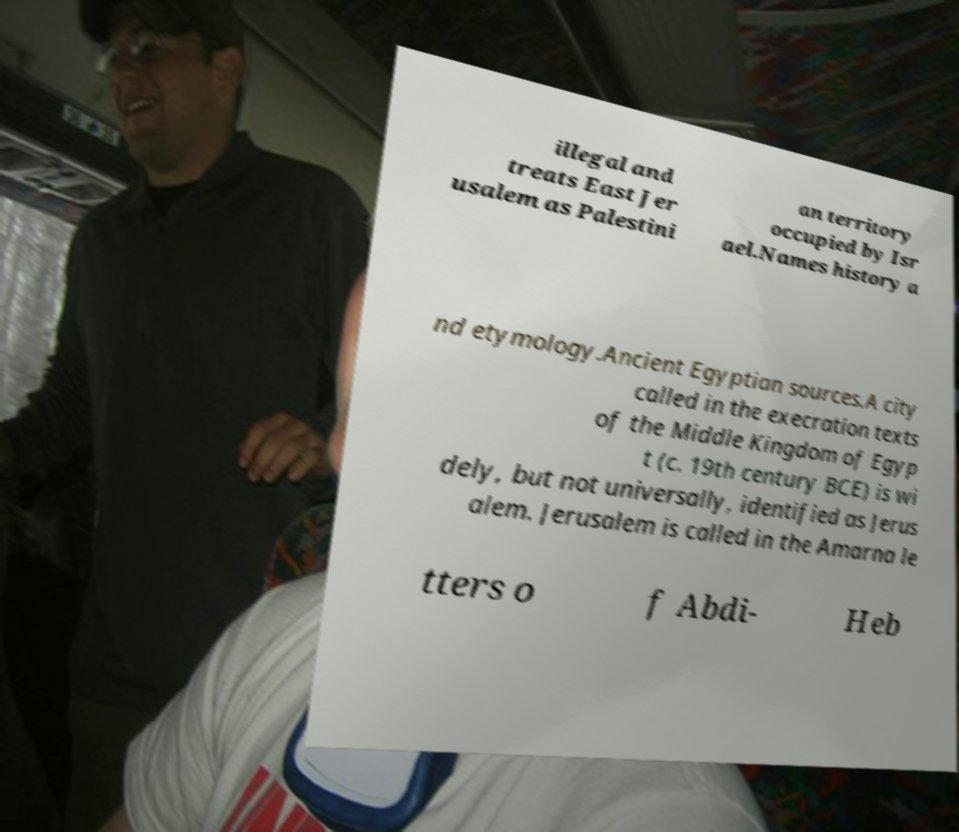There's text embedded in this image that I need extracted. Can you transcribe it verbatim? illegal and treats East Jer usalem as Palestini an territory occupied by Isr ael.Names history a nd etymology.Ancient Egyptian sources.A city called in the execration texts of the Middle Kingdom of Egyp t (c. 19th century BCE) is wi dely, but not universally, identified as Jerus alem. Jerusalem is called in the Amarna le tters o f Abdi- Heb 